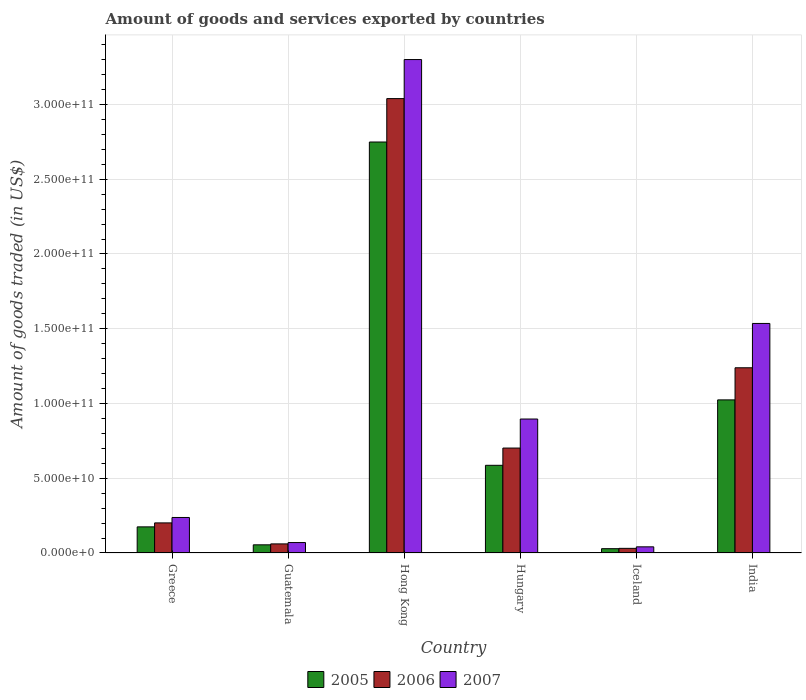How many groups of bars are there?
Provide a succinct answer. 6. Are the number of bars on each tick of the X-axis equal?
Provide a short and direct response. Yes. How many bars are there on the 1st tick from the left?
Make the answer very short. 3. What is the total amount of goods and services exported in 2007 in Hong Kong?
Offer a terse response. 3.30e+11. Across all countries, what is the maximum total amount of goods and services exported in 2007?
Keep it short and to the point. 3.30e+11. Across all countries, what is the minimum total amount of goods and services exported in 2007?
Offer a very short reply. 4.12e+09. In which country was the total amount of goods and services exported in 2006 maximum?
Offer a terse response. Hong Kong. In which country was the total amount of goods and services exported in 2007 minimum?
Your answer should be very brief. Iceland. What is the total total amount of goods and services exported in 2005 in the graph?
Ensure brevity in your answer.  4.62e+11. What is the difference between the total amount of goods and services exported in 2005 in Hong Kong and that in India?
Provide a succinct answer. 1.72e+11. What is the difference between the total amount of goods and services exported in 2005 in Greece and the total amount of goods and services exported in 2006 in Iceland?
Your answer should be compact. 1.44e+1. What is the average total amount of goods and services exported in 2006 per country?
Your answer should be very brief. 8.79e+1. What is the difference between the total amount of goods and services exported of/in 2006 and total amount of goods and services exported of/in 2005 in India?
Your response must be concise. 2.15e+1. In how many countries, is the total amount of goods and services exported in 2006 greater than 100000000000 US$?
Make the answer very short. 2. What is the ratio of the total amount of goods and services exported in 2005 in Greece to that in Guatemala?
Ensure brevity in your answer.  3.2. Is the difference between the total amount of goods and services exported in 2006 in Guatemala and Hungary greater than the difference between the total amount of goods and services exported in 2005 in Guatemala and Hungary?
Provide a succinct answer. No. What is the difference between the highest and the second highest total amount of goods and services exported in 2006?
Offer a very short reply. 1.80e+11. What is the difference between the highest and the lowest total amount of goods and services exported in 2006?
Make the answer very short. 3.01e+11. In how many countries, is the total amount of goods and services exported in 2005 greater than the average total amount of goods and services exported in 2005 taken over all countries?
Ensure brevity in your answer.  2. What does the 2nd bar from the right in Iceland represents?
Provide a short and direct response. 2006. How many bars are there?
Make the answer very short. 18. How many countries are there in the graph?
Your answer should be very brief. 6. What is the difference between two consecutive major ticks on the Y-axis?
Provide a succinct answer. 5.00e+1. Does the graph contain any zero values?
Your answer should be compact. No. How many legend labels are there?
Your answer should be compact. 3. How are the legend labels stacked?
Your answer should be very brief. Horizontal. What is the title of the graph?
Offer a very short reply. Amount of goods and services exported by countries. What is the label or title of the Y-axis?
Provide a short and direct response. Amount of goods traded (in US$). What is the Amount of goods traded (in US$) in 2005 in Greece?
Ensure brevity in your answer.  1.75e+1. What is the Amount of goods traded (in US$) of 2006 in Greece?
Keep it short and to the point. 2.01e+1. What is the Amount of goods traded (in US$) in 2007 in Greece?
Make the answer very short. 2.38e+1. What is the Amount of goods traded (in US$) of 2005 in Guatemala?
Ensure brevity in your answer.  5.46e+09. What is the Amount of goods traded (in US$) in 2006 in Guatemala?
Your response must be concise. 6.08e+09. What is the Amount of goods traded (in US$) of 2007 in Guatemala?
Keep it short and to the point. 6.98e+09. What is the Amount of goods traded (in US$) of 2005 in Hong Kong?
Give a very brief answer. 2.75e+11. What is the Amount of goods traded (in US$) of 2006 in Hong Kong?
Your answer should be compact. 3.04e+11. What is the Amount of goods traded (in US$) of 2007 in Hong Kong?
Give a very brief answer. 3.30e+11. What is the Amount of goods traded (in US$) in 2005 in Hungary?
Give a very brief answer. 5.86e+1. What is the Amount of goods traded (in US$) of 2006 in Hungary?
Make the answer very short. 7.02e+1. What is the Amount of goods traded (in US$) of 2007 in Hungary?
Your answer should be compact. 8.96e+1. What is the Amount of goods traded (in US$) of 2005 in Iceland?
Give a very brief answer. 2.89e+09. What is the Amount of goods traded (in US$) in 2006 in Iceland?
Keep it short and to the point. 3.10e+09. What is the Amount of goods traded (in US$) in 2007 in Iceland?
Provide a succinct answer. 4.12e+09. What is the Amount of goods traded (in US$) in 2005 in India?
Make the answer very short. 1.02e+11. What is the Amount of goods traded (in US$) of 2006 in India?
Keep it short and to the point. 1.24e+11. What is the Amount of goods traded (in US$) of 2007 in India?
Your response must be concise. 1.54e+11. Across all countries, what is the maximum Amount of goods traded (in US$) of 2005?
Offer a very short reply. 2.75e+11. Across all countries, what is the maximum Amount of goods traded (in US$) in 2006?
Offer a terse response. 3.04e+11. Across all countries, what is the maximum Amount of goods traded (in US$) in 2007?
Give a very brief answer. 3.30e+11. Across all countries, what is the minimum Amount of goods traded (in US$) of 2005?
Provide a succinct answer. 2.89e+09. Across all countries, what is the minimum Amount of goods traded (in US$) of 2006?
Your answer should be very brief. 3.10e+09. Across all countries, what is the minimum Amount of goods traded (in US$) in 2007?
Provide a short and direct response. 4.12e+09. What is the total Amount of goods traded (in US$) in 2005 in the graph?
Make the answer very short. 4.62e+11. What is the total Amount of goods traded (in US$) of 2006 in the graph?
Your answer should be compact. 5.27e+11. What is the total Amount of goods traded (in US$) of 2007 in the graph?
Give a very brief answer. 6.08e+11. What is the difference between the Amount of goods traded (in US$) in 2005 in Greece and that in Guatemala?
Your response must be concise. 1.20e+1. What is the difference between the Amount of goods traded (in US$) in 2006 in Greece and that in Guatemala?
Give a very brief answer. 1.40e+1. What is the difference between the Amount of goods traded (in US$) of 2007 in Greece and that in Guatemala?
Provide a succinct answer. 1.68e+1. What is the difference between the Amount of goods traded (in US$) in 2005 in Greece and that in Hong Kong?
Your response must be concise. -2.57e+11. What is the difference between the Amount of goods traded (in US$) of 2006 in Greece and that in Hong Kong?
Your answer should be very brief. -2.84e+11. What is the difference between the Amount of goods traded (in US$) of 2007 in Greece and that in Hong Kong?
Keep it short and to the point. -3.06e+11. What is the difference between the Amount of goods traded (in US$) of 2005 in Greece and that in Hungary?
Keep it short and to the point. -4.12e+1. What is the difference between the Amount of goods traded (in US$) of 2006 in Greece and that in Hungary?
Offer a terse response. -5.01e+1. What is the difference between the Amount of goods traded (in US$) in 2007 in Greece and that in Hungary?
Your response must be concise. -6.59e+1. What is the difference between the Amount of goods traded (in US$) of 2005 in Greece and that in Iceland?
Offer a terse response. 1.46e+1. What is the difference between the Amount of goods traded (in US$) in 2006 in Greece and that in Iceland?
Offer a very short reply. 1.70e+1. What is the difference between the Amount of goods traded (in US$) of 2007 in Greece and that in Iceland?
Provide a succinct answer. 1.96e+1. What is the difference between the Amount of goods traded (in US$) of 2005 in Greece and that in India?
Offer a very short reply. -8.49e+1. What is the difference between the Amount of goods traded (in US$) in 2006 in Greece and that in India?
Keep it short and to the point. -1.04e+11. What is the difference between the Amount of goods traded (in US$) of 2007 in Greece and that in India?
Make the answer very short. -1.30e+11. What is the difference between the Amount of goods traded (in US$) of 2005 in Guatemala and that in Hong Kong?
Offer a very short reply. -2.69e+11. What is the difference between the Amount of goods traded (in US$) of 2006 in Guatemala and that in Hong Kong?
Provide a short and direct response. -2.98e+11. What is the difference between the Amount of goods traded (in US$) in 2007 in Guatemala and that in Hong Kong?
Your response must be concise. -3.23e+11. What is the difference between the Amount of goods traded (in US$) of 2005 in Guatemala and that in Hungary?
Give a very brief answer. -5.32e+1. What is the difference between the Amount of goods traded (in US$) in 2006 in Guatemala and that in Hungary?
Make the answer very short. -6.41e+1. What is the difference between the Amount of goods traded (in US$) of 2007 in Guatemala and that in Hungary?
Offer a very short reply. -8.26e+1. What is the difference between the Amount of goods traded (in US$) in 2005 in Guatemala and that in Iceland?
Your answer should be very brief. 2.57e+09. What is the difference between the Amount of goods traded (in US$) in 2006 in Guatemala and that in Iceland?
Ensure brevity in your answer.  2.98e+09. What is the difference between the Amount of goods traded (in US$) in 2007 in Guatemala and that in Iceland?
Your answer should be compact. 2.86e+09. What is the difference between the Amount of goods traded (in US$) in 2005 in Guatemala and that in India?
Ensure brevity in your answer.  -9.69e+1. What is the difference between the Amount of goods traded (in US$) of 2006 in Guatemala and that in India?
Ensure brevity in your answer.  -1.18e+11. What is the difference between the Amount of goods traded (in US$) in 2007 in Guatemala and that in India?
Offer a terse response. -1.47e+11. What is the difference between the Amount of goods traded (in US$) of 2005 in Hong Kong and that in Hungary?
Your response must be concise. 2.16e+11. What is the difference between the Amount of goods traded (in US$) of 2006 in Hong Kong and that in Hungary?
Give a very brief answer. 2.34e+11. What is the difference between the Amount of goods traded (in US$) in 2007 in Hong Kong and that in Hungary?
Your answer should be very brief. 2.40e+11. What is the difference between the Amount of goods traded (in US$) in 2005 in Hong Kong and that in Iceland?
Your response must be concise. 2.72e+11. What is the difference between the Amount of goods traded (in US$) of 2006 in Hong Kong and that in Iceland?
Your answer should be compact. 3.01e+11. What is the difference between the Amount of goods traded (in US$) of 2007 in Hong Kong and that in Iceland?
Provide a short and direct response. 3.26e+11. What is the difference between the Amount of goods traded (in US$) in 2005 in Hong Kong and that in India?
Your answer should be compact. 1.72e+11. What is the difference between the Amount of goods traded (in US$) in 2006 in Hong Kong and that in India?
Ensure brevity in your answer.  1.80e+11. What is the difference between the Amount of goods traded (in US$) of 2007 in Hong Kong and that in India?
Keep it short and to the point. 1.77e+11. What is the difference between the Amount of goods traded (in US$) in 2005 in Hungary and that in Iceland?
Provide a short and direct response. 5.58e+1. What is the difference between the Amount of goods traded (in US$) in 2006 in Hungary and that in Iceland?
Provide a short and direct response. 6.71e+1. What is the difference between the Amount of goods traded (in US$) in 2007 in Hungary and that in Iceland?
Provide a short and direct response. 8.55e+1. What is the difference between the Amount of goods traded (in US$) in 2005 in Hungary and that in India?
Your answer should be compact. -4.38e+1. What is the difference between the Amount of goods traded (in US$) in 2006 in Hungary and that in India?
Your answer should be very brief. -5.37e+1. What is the difference between the Amount of goods traded (in US$) of 2007 in Hungary and that in India?
Provide a succinct answer. -6.39e+1. What is the difference between the Amount of goods traded (in US$) of 2005 in Iceland and that in India?
Make the answer very short. -9.95e+1. What is the difference between the Amount of goods traded (in US$) of 2006 in Iceland and that in India?
Your response must be concise. -1.21e+11. What is the difference between the Amount of goods traded (in US$) of 2007 in Iceland and that in India?
Your answer should be very brief. -1.49e+11. What is the difference between the Amount of goods traded (in US$) of 2005 in Greece and the Amount of goods traded (in US$) of 2006 in Guatemala?
Offer a very short reply. 1.14e+1. What is the difference between the Amount of goods traded (in US$) in 2005 in Greece and the Amount of goods traded (in US$) in 2007 in Guatemala?
Your response must be concise. 1.05e+1. What is the difference between the Amount of goods traded (in US$) in 2006 in Greece and the Amount of goods traded (in US$) in 2007 in Guatemala?
Provide a succinct answer. 1.31e+1. What is the difference between the Amount of goods traded (in US$) in 2005 in Greece and the Amount of goods traded (in US$) in 2006 in Hong Kong?
Provide a succinct answer. -2.86e+11. What is the difference between the Amount of goods traded (in US$) in 2005 in Greece and the Amount of goods traded (in US$) in 2007 in Hong Kong?
Offer a very short reply. -3.13e+11. What is the difference between the Amount of goods traded (in US$) of 2006 in Greece and the Amount of goods traded (in US$) of 2007 in Hong Kong?
Provide a succinct answer. -3.10e+11. What is the difference between the Amount of goods traded (in US$) in 2005 in Greece and the Amount of goods traded (in US$) in 2006 in Hungary?
Offer a terse response. -5.27e+1. What is the difference between the Amount of goods traded (in US$) of 2005 in Greece and the Amount of goods traded (in US$) of 2007 in Hungary?
Provide a succinct answer. -7.21e+1. What is the difference between the Amount of goods traded (in US$) in 2006 in Greece and the Amount of goods traded (in US$) in 2007 in Hungary?
Your response must be concise. -6.95e+1. What is the difference between the Amount of goods traded (in US$) in 2005 in Greece and the Amount of goods traded (in US$) in 2006 in Iceland?
Your answer should be very brief. 1.44e+1. What is the difference between the Amount of goods traded (in US$) of 2005 in Greece and the Amount of goods traded (in US$) of 2007 in Iceland?
Offer a terse response. 1.34e+1. What is the difference between the Amount of goods traded (in US$) of 2006 in Greece and the Amount of goods traded (in US$) of 2007 in Iceland?
Keep it short and to the point. 1.60e+1. What is the difference between the Amount of goods traded (in US$) of 2005 in Greece and the Amount of goods traded (in US$) of 2006 in India?
Your response must be concise. -1.06e+11. What is the difference between the Amount of goods traded (in US$) of 2005 in Greece and the Amount of goods traded (in US$) of 2007 in India?
Your response must be concise. -1.36e+11. What is the difference between the Amount of goods traded (in US$) of 2006 in Greece and the Amount of goods traded (in US$) of 2007 in India?
Offer a very short reply. -1.33e+11. What is the difference between the Amount of goods traded (in US$) of 2005 in Guatemala and the Amount of goods traded (in US$) of 2006 in Hong Kong?
Your answer should be very brief. -2.98e+11. What is the difference between the Amount of goods traded (in US$) in 2005 in Guatemala and the Amount of goods traded (in US$) in 2007 in Hong Kong?
Keep it short and to the point. -3.25e+11. What is the difference between the Amount of goods traded (in US$) in 2006 in Guatemala and the Amount of goods traded (in US$) in 2007 in Hong Kong?
Offer a terse response. -3.24e+11. What is the difference between the Amount of goods traded (in US$) of 2005 in Guatemala and the Amount of goods traded (in US$) of 2006 in Hungary?
Provide a short and direct response. -6.47e+1. What is the difference between the Amount of goods traded (in US$) in 2005 in Guatemala and the Amount of goods traded (in US$) in 2007 in Hungary?
Provide a succinct answer. -8.41e+1. What is the difference between the Amount of goods traded (in US$) of 2006 in Guatemala and the Amount of goods traded (in US$) of 2007 in Hungary?
Offer a terse response. -8.35e+1. What is the difference between the Amount of goods traded (in US$) of 2005 in Guatemala and the Amount of goods traded (in US$) of 2006 in Iceland?
Your response must be concise. 2.36e+09. What is the difference between the Amount of goods traded (in US$) in 2005 in Guatemala and the Amount of goods traded (in US$) in 2007 in Iceland?
Provide a succinct answer. 1.34e+09. What is the difference between the Amount of goods traded (in US$) of 2006 in Guatemala and the Amount of goods traded (in US$) of 2007 in Iceland?
Provide a short and direct response. 1.96e+09. What is the difference between the Amount of goods traded (in US$) of 2005 in Guatemala and the Amount of goods traded (in US$) of 2006 in India?
Your answer should be compact. -1.18e+11. What is the difference between the Amount of goods traded (in US$) of 2005 in Guatemala and the Amount of goods traded (in US$) of 2007 in India?
Offer a very short reply. -1.48e+11. What is the difference between the Amount of goods traded (in US$) in 2006 in Guatemala and the Amount of goods traded (in US$) in 2007 in India?
Give a very brief answer. -1.47e+11. What is the difference between the Amount of goods traded (in US$) of 2005 in Hong Kong and the Amount of goods traded (in US$) of 2006 in Hungary?
Provide a short and direct response. 2.05e+11. What is the difference between the Amount of goods traded (in US$) in 2005 in Hong Kong and the Amount of goods traded (in US$) in 2007 in Hungary?
Your answer should be compact. 1.85e+11. What is the difference between the Amount of goods traded (in US$) of 2006 in Hong Kong and the Amount of goods traded (in US$) of 2007 in Hungary?
Your response must be concise. 2.14e+11. What is the difference between the Amount of goods traded (in US$) in 2005 in Hong Kong and the Amount of goods traded (in US$) in 2006 in Iceland?
Offer a terse response. 2.72e+11. What is the difference between the Amount of goods traded (in US$) in 2005 in Hong Kong and the Amount of goods traded (in US$) in 2007 in Iceland?
Offer a terse response. 2.71e+11. What is the difference between the Amount of goods traded (in US$) in 2006 in Hong Kong and the Amount of goods traded (in US$) in 2007 in Iceland?
Make the answer very short. 3.00e+11. What is the difference between the Amount of goods traded (in US$) of 2005 in Hong Kong and the Amount of goods traded (in US$) of 2006 in India?
Keep it short and to the point. 1.51e+11. What is the difference between the Amount of goods traded (in US$) in 2005 in Hong Kong and the Amount of goods traded (in US$) in 2007 in India?
Your response must be concise. 1.21e+11. What is the difference between the Amount of goods traded (in US$) of 2006 in Hong Kong and the Amount of goods traded (in US$) of 2007 in India?
Offer a very short reply. 1.50e+11. What is the difference between the Amount of goods traded (in US$) of 2005 in Hungary and the Amount of goods traded (in US$) of 2006 in Iceland?
Ensure brevity in your answer.  5.55e+1. What is the difference between the Amount of goods traded (in US$) of 2005 in Hungary and the Amount of goods traded (in US$) of 2007 in Iceland?
Offer a terse response. 5.45e+1. What is the difference between the Amount of goods traded (in US$) in 2006 in Hungary and the Amount of goods traded (in US$) in 2007 in Iceland?
Your answer should be compact. 6.61e+1. What is the difference between the Amount of goods traded (in US$) of 2005 in Hungary and the Amount of goods traded (in US$) of 2006 in India?
Provide a short and direct response. -6.52e+1. What is the difference between the Amount of goods traded (in US$) of 2005 in Hungary and the Amount of goods traded (in US$) of 2007 in India?
Ensure brevity in your answer.  -9.49e+1. What is the difference between the Amount of goods traded (in US$) in 2006 in Hungary and the Amount of goods traded (in US$) in 2007 in India?
Ensure brevity in your answer.  -8.33e+1. What is the difference between the Amount of goods traded (in US$) in 2005 in Iceland and the Amount of goods traded (in US$) in 2006 in India?
Offer a terse response. -1.21e+11. What is the difference between the Amount of goods traded (in US$) in 2005 in Iceland and the Amount of goods traded (in US$) in 2007 in India?
Your answer should be compact. -1.51e+11. What is the difference between the Amount of goods traded (in US$) in 2006 in Iceland and the Amount of goods traded (in US$) in 2007 in India?
Your answer should be compact. -1.50e+11. What is the average Amount of goods traded (in US$) of 2005 per country?
Provide a short and direct response. 7.70e+1. What is the average Amount of goods traded (in US$) of 2006 per country?
Offer a very short reply. 8.79e+1. What is the average Amount of goods traded (in US$) in 2007 per country?
Offer a very short reply. 1.01e+11. What is the difference between the Amount of goods traded (in US$) in 2005 and Amount of goods traded (in US$) in 2006 in Greece?
Provide a succinct answer. -2.66e+09. What is the difference between the Amount of goods traded (in US$) in 2005 and Amount of goods traded (in US$) in 2007 in Greece?
Offer a very short reply. -6.28e+09. What is the difference between the Amount of goods traded (in US$) of 2006 and Amount of goods traded (in US$) of 2007 in Greece?
Keep it short and to the point. -3.62e+09. What is the difference between the Amount of goods traded (in US$) in 2005 and Amount of goods traded (in US$) in 2006 in Guatemala?
Your answer should be compact. -6.23e+08. What is the difference between the Amount of goods traded (in US$) of 2005 and Amount of goods traded (in US$) of 2007 in Guatemala?
Offer a terse response. -1.52e+09. What is the difference between the Amount of goods traded (in US$) in 2006 and Amount of goods traded (in US$) in 2007 in Guatemala?
Offer a terse response. -9.01e+08. What is the difference between the Amount of goods traded (in US$) of 2005 and Amount of goods traded (in US$) of 2006 in Hong Kong?
Your answer should be compact. -2.90e+1. What is the difference between the Amount of goods traded (in US$) of 2005 and Amount of goods traded (in US$) of 2007 in Hong Kong?
Make the answer very short. -5.52e+1. What is the difference between the Amount of goods traded (in US$) in 2006 and Amount of goods traded (in US$) in 2007 in Hong Kong?
Offer a very short reply. -2.61e+1. What is the difference between the Amount of goods traded (in US$) in 2005 and Amount of goods traded (in US$) in 2006 in Hungary?
Offer a very short reply. -1.15e+1. What is the difference between the Amount of goods traded (in US$) of 2005 and Amount of goods traded (in US$) of 2007 in Hungary?
Offer a terse response. -3.10e+1. What is the difference between the Amount of goods traded (in US$) in 2006 and Amount of goods traded (in US$) in 2007 in Hungary?
Provide a succinct answer. -1.94e+1. What is the difference between the Amount of goods traded (in US$) of 2005 and Amount of goods traded (in US$) of 2006 in Iceland?
Give a very brief answer. -2.13e+08. What is the difference between the Amount of goods traded (in US$) in 2005 and Amount of goods traded (in US$) in 2007 in Iceland?
Your answer should be very brief. -1.23e+09. What is the difference between the Amount of goods traded (in US$) in 2006 and Amount of goods traded (in US$) in 2007 in Iceland?
Keep it short and to the point. -1.02e+09. What is the difference between the Amount of goods traded (in US$) in 2005 and Amount of goods traded (in US$) in 2006 in India?
Your answer should be very brief. -2.15e+1. What is the difference between the Amount of goods traded (in US$) of 2005 and Amount of goods traded (in US$) of 2007 in India?
Your answer should be very brief. -5.11e+1. What is the difference between the Amount of goods traded (in US$) in 2006 and Amount of goods traded (in US$) in 2007 in India?
Offer a very short reply. -2.97e+1. What is the ratio of the Amount of goods traded (in US$) in 2005 in Greece to that in Guatemala?
Give a very brief answer. 3.2. What is the ratio of the Amount of goods traded (in US$) in 2006 in Greece to that in Guatemala?
Your response must be concise. 3.31. What is the ratio of the Amount of goods traded (in US$) in 2007 in Greece to that in Guatemala?
Ensure brevity in your answer.  3.4. What is the ratio of the Amount of goods traded (in US$) of 2005 in Greece to that in Hong Kong?
Your answer should be very brief. 0.06. What is the ratio of the Amount of goods traded (in US$) of 2006 in Greece to that in Hong Kong?
Provide a succinct answer. 0.07. What is the ratio of the Amount of goods traded (in US$) in 2007 in Greece to that in Hong Kong?
Give a very brief answer. 0.07. What is the ratio of the Amount of goods traded (in US$) in 2005 in Greece to that in Hungary?
Your answer should be compact. 0.3. What is the ratio of the Amount of goods traded (in US$) in 2006 in Greece to that in Hungary?
Give a very brief answer. 0.29. What is the ratio of the Amount of goods traded (in US$) of 2007 in Greece to that in Hungary?
Provide a succinct answer. 0.27. What is the ratio of the Amount of goods traded (in US$) of 2005 in Greece to that in Iceland?
Make the answer very short. 6.05. What is the ratio of the Amount of goods traded (in US$) of 2006 in Greece to that in Iceland?
Ensure brevity in your answer.  6.5. What is the ratio of the Amount of goods traded (in US$) of 2007 in Greece to that in Iceland?
Your response must be concise. 5.77. What is the ratio of the Amount of goods traded (in US$) of 2005 in Greece to that in India?
Provide a succinct answer. 0.17. What is the ratio of the Amount of goods traded (in US$) in 2006 in Greece to that in India?
Provide a short and direct response. 0.16. What is the ratio of the Amount of goods traded (in US$) of 2007 in Greece to that in India?
Provide a succinct answer. 0.15. What is the ratio of the Amount of goods traded (in US$) of 2005 in Guatemala to that in Hong Kong?
Give a very brief answer. 0.02. What is the ratio of the Amount of goods traded (in US$) in 2006 in Guatemala to that in Hong Kong?
Give a very brief answer. 0.02. What is the ratio of the Amount of goods traded (in US$) of 2007 in Guatemala to that in Hong Kong?
Give a very brief answer. 0.02. What is the ratio of the Amount of goods traded (in US$) of 2005 in Guatemala to that in Hungary?
Ensure brevity in your answer.  0.09. What is the ratio of the Amount of goods traded (in US$) of 2006 in Guatemala to that in Hungary?
Keep it short and to the point. 0.09. What is the ratio of the Amount of goods traded (in US$) of 2007 in Guatemala to that in Hungary?
Offer a very short reply. 0.08. What is the ratio of the Amount of goods traded (in US$) in 2005 in Guatemala to that in Iceland?
Provide a short and direct response. 1.89. What is the ratio of the Amount of goods traded (in US$) of 2006 in Guatemala to that in Iceland?
Give a very brief answer. 1.96. What is the ratio of the Amount of goods traded (in US$) in 2007 in Guatemala to that in Iceland?
Give a very brief answer. 1.7. What is the ratio of the Amount of goods traded (in US$) of 2005 in Guatemala to that in India?
Your answer should be compact. 0.05. What is the ratio of the Amount of goods traded (in US$) in 2006 in Guatemala to that in India?
Keep it short and to the point. 0.05. What is the ratio of the Amount of goods traded (in US$) of 2007 in Guatemala to that in India?
Provide a short and direct response. 0.05. What is the ratio of the Amount of goods traded (in US$) in 2005 in Hong Kong to that in Hungary?
Make the answer very short. 4.69. What is the ratio of the Amount of goods traded (in US$) in 2006 in Hong Kong to that in Hungary?
Make the answer very short. 4.33. What is the ratio of the Amount of goods traded (in US$) in 2007 in Hong Kong to that in Hungary?
Make the answer very short. 3.68. What is the ratio of the Amount of goods traded (in US$) of 2005 in Hong Kong to that in Iceland?
Provide a short and direct response. 95.26. What is the ratio of the Amount of goods traded (in US$) in 2006 in Hong Kong to that in Iceland?
Make the answer very short. 98.08. What is the ratio of the Amount of goods traded (in US$) in 2007 in Hong Kong to that in Iceland?
Your answer should be compact. 80.14. What is the ratio of the Amount of goods traded (in US$) of 2005 in Hong Kong to that in India?
Your answer should be compact. 2.68. What is the ratio of the Amount of goods traded (in US$) of 2006 in Hong Kong to that in India?
Give a very brief answer. 2.45. What is the ratio of the Amount of goods traded (in US$) of 2007 in Hong Kong to that in India?
Offer a terse response. 2.15. What is the ratio of the Amount of goods traded (in US$) in 2005 in Hungary to that in Iceland?
Ensure brevity in your answer.  20.32. What is the ratio of the Amount of goods traded (in US$) of 2006 in Hungary to that in Iceland?
Ensure brevity in your answer.  22.65. What is the ratio of the Amount of goods traded (in US$) in 2007 in Hungary to that in Iceland?
Give a very brief answer. 21.76. What is the ratio of the Amount of goods traded (in US$) of 2005 in Hungary to that in India?
Ensure brevity in your answer.  0.57. What is the ratio of the Amount of goods traded (in US$) in 2006 in Hungary to that in India?
Keep it short and to the point. 0.57. What is the ratio of the Amount of goods traded (in US$) of 2007 in Hungary to that in India?
Provide a short and direct response. 0.58. What is the ratio of the Amount of goods traded (in US$) in 2005 in Iceland to that in India?
Offer a terse response. 0.03. What is the ratio of the Amount of goods traded (in US$) in 2006 in Iceland to that in India?
Ensure brevity in your answer.  0.03. What is the ratio of the Amount of goods traded (in US$) of 2007 in Iceland to that in India?
Give a very brief answer. 0.03. What is the difference between the highest and the second highest Amount of goods traded (in US$) of 2005?
Offer a terse response. 1.72e+11. What is the difference between the highest and the second highest Amount of goods traded (in US$) of 2006?
Provide a succinct answer. 1.80e+11. What is the difference between the highest and the second highest Amount of goods traded (in US$) in 2007?
Provide a succinct answer. 1.77e+11. What is the difference between the highest and the lowest Amount of goods traded (in US$) in 2005?
Provide a short and direct response. 2.72e+11. What is the difference between the highest and the lowest Amount of goods traded (in US$) in 2006?
Provide a short and direct response. 3.01e+11. What is the difference between the highest and the lowest Amount of goods traded (in US$) of 2007?
Give a very brief answer. 3.26e+11. 